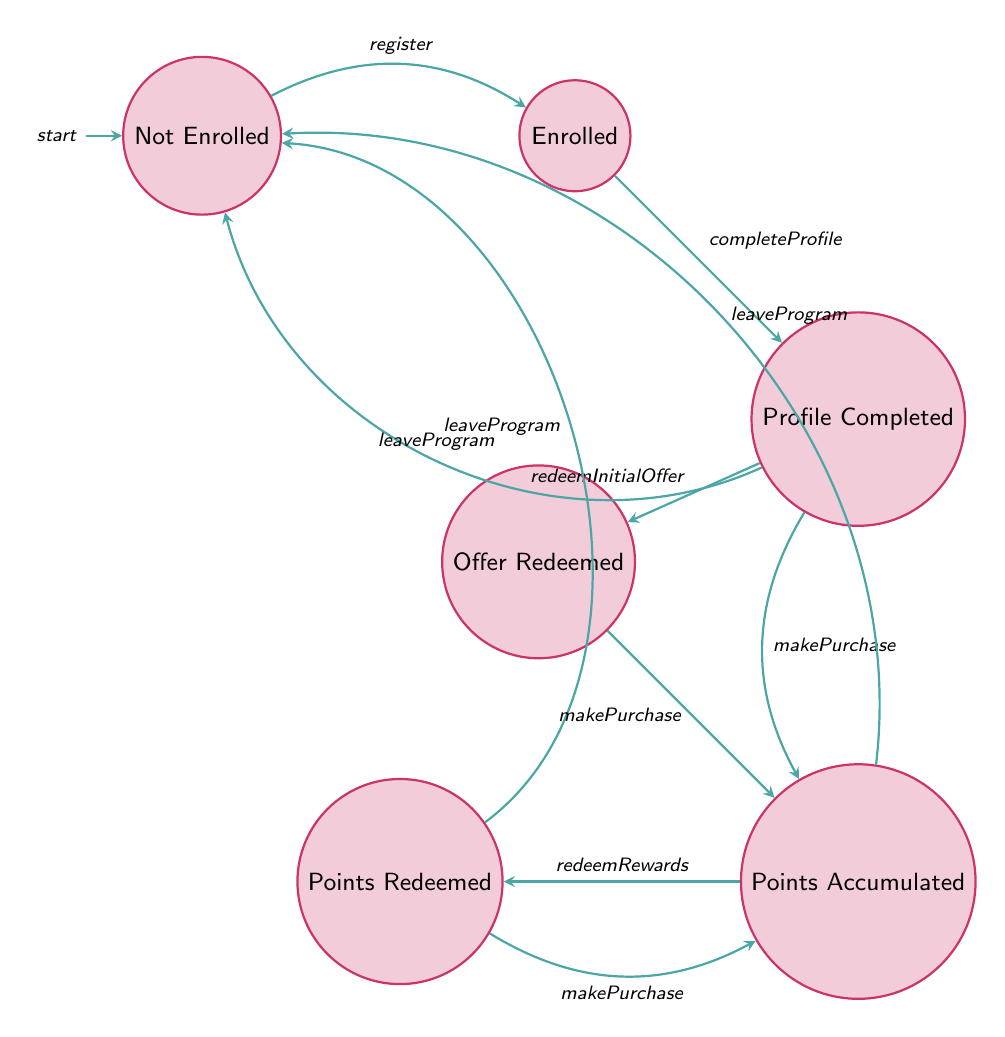What is the starting state of the process? The starting state is labeled "Not Enrolled" in the diagram, indicated as the initial state from which the transitions begin.
Answer: Not Enrolled How many total states are there? By counting the nodes, we see there are six states: Not Enrolled, Enrolled, Profile Completed, Points Accumulated, Points Redeemed, and Offer Redeemed.
Answer: Six What action occurs when transitioning from "Not Enrolled" to "Enrolled"? The transition from "Not Enrolled" to "Enrolled" is triggered by the action "register," which involves the collection of basic information from the user.
Answer: Collect Basic Information Which state allows for the redemption of rewards? The state "Points Accumulated" has a transition that allows users to redeem rewards through the trigger "redeemRewards."
Answer: Points Accumulated What action is taken when redeeming the initial offer? The action that occurs when "redeemInitialOffer" is triggered in the "Profile Completed" state is "Apply Welcome Discount."
Answer: Apply Welcome Discount Which states can lead directly back to "Not Enrolled"? The states that have a transition leading back to "Not Enrolled" are "Profile Completed," "Points Accumulated," and "Points Redeemed," each allowing the user to leave the program.
Answer: Profile Completed, Points Accumulated, Points Redeemed When a user makes a purchase from "Offer Redeemed," which state do they transition to? If a user makes a purchase while in the "Offer Redeemed" state, they transition to "Points Accumulated," indicating that their points balance will be updated as a result of the purchase.
Answer: Points Accumulated How many transitions exist from the "Profile Completed" state? In the "Profile Completed" state, there are three outgoing transitions: one to "Points Accumulated," one to "Offer Redeemed," and one to "Not Enrolled," totaling three transitions.
Answer: Three What is the result of the "redeemRewards" trigger in the "Points Accumulated" state? The "redeemRewards" trigger results in moving the process to the "Points Redeemed" state while deducting points from the user's balance in the process.
Answer: Points Redeemed 